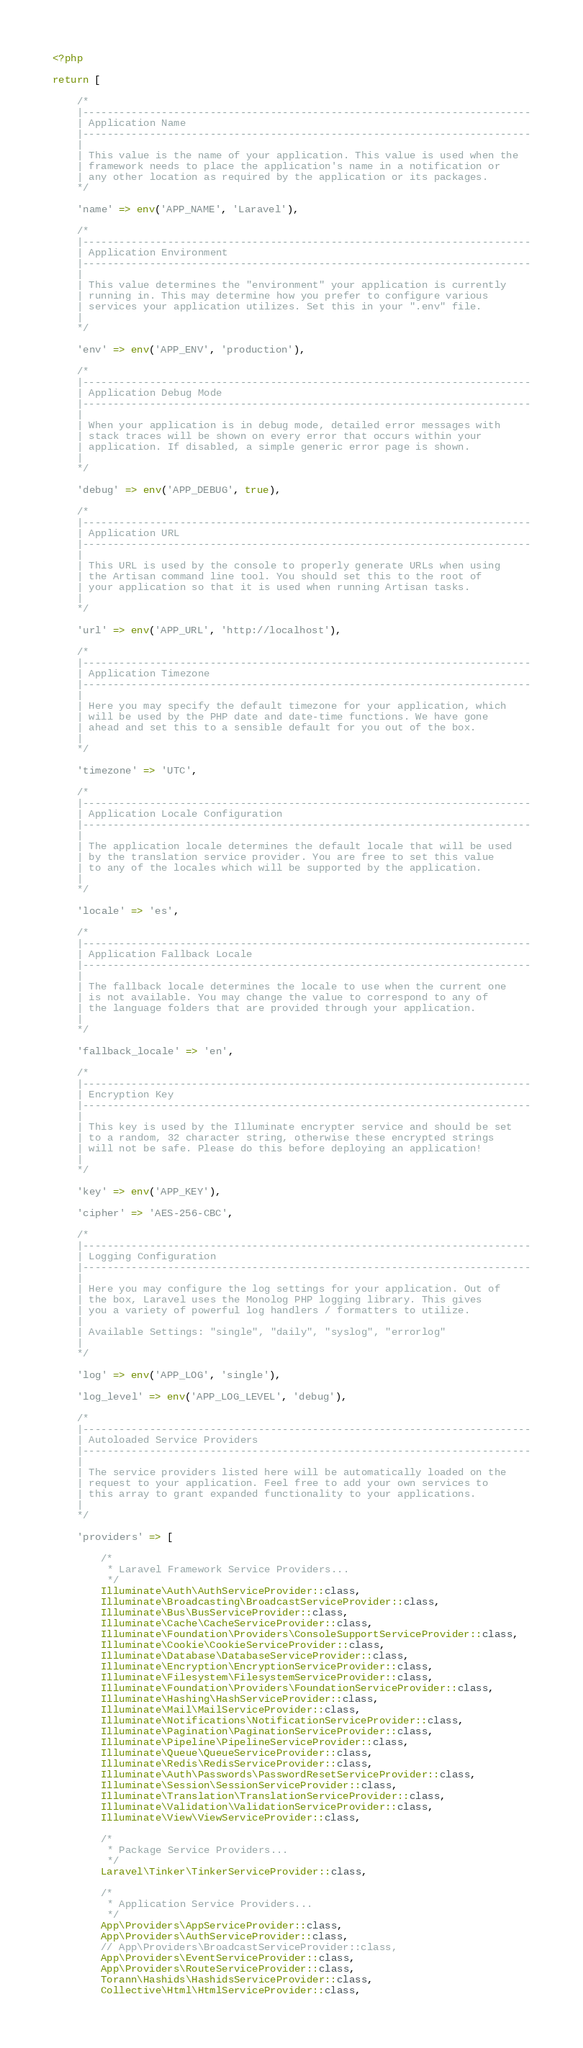Convert code to text. <code><loc_0><loc_0><loc_500><loc_500><_PHP_><?php

return [

    /*
    |--------------------------------------------------------------------------
    | Application Name
    |--------------------------------------------------------------------------
    |
    | This value is the name of your application. This value is used when the
    | framework needs to place the application's name in a notification or
    | any other location as required by the application or its packages.
    */

    'name' => env('APP_NAME', 'Laravel'),

    /*
    |--------------------------------------------------------------------------
    | Application Environment
    |--------------------------------------------------------------------------
    |
    | This value determines the "environment" your application is currently
    | running in. This may determine how you prefer to configure various
    | services your application utilizes. Set this in your ".env" file.
    |
    */

    'env' => env('APP_ENV', 'production'),

    /*
    |--------------------------------------------------------------------------
    | Application Debug Mode
    |--------------------------------------------------------------------------
    |
    | When your application is in debug mode, detailed error messages with
    | stack traces will be shown on every error that occurs within your
    | application. If disabled, a simple generic error page is shown.
    |
    */

    'debug' => env('APP_DEBUG', true),

    /*
    |--------------------------------------------------------------------------
    | Application URL
    |--------------------------------------------------------------------------
    |
    | This URL is used by the console to properly generate URLs when using
    | the Artisan command line tool. You should set this to the root of
    | your application so that it is used when running Artisan tasks.
    |
    */

    'url' => env('APP_URL', 'http://localhost'),

    /*
    |--------------------------------------------------------------------------
    | Application Timezone
    |--------------------------------------------------------------------------
    |
    | Here you may specify the default timezone for your application, which
    | will be used by the PHP date and date-time functions. We have gone
    | ahead and set this to a sensible default for you out of the box.
    |
    */

    'timezone' => 'UTC',

    /*
    |--------------------------------------------------------------------------
    | Application Locale Configuration
    |--------------------------------------------------------------------------
    |
    | The application locale determines the default locale that will be used
    | by the translation service provider. You are free to set this value
    | to any of the locales which will be supported by the application.
    |
    */

    'locale' => 'es',

    /*
    |--------------------------------------------------------------------------
    | Application Fallback Locale
    |--------------------------------------------------------------------------
    |
    | The fallback locale determines the locale to use when the current one
    | is not available. You may change the value to correspond to any of
    | the language folders that are provided through your application.
    |
    */

    'fallback_locale' => 'en',

    /*
    |--------------------------------------------------------------------------
    | Encryption Key
    |--------------------------------------------------------------------------
    |
    | This key is used by the Illuminate encrypter service and should be set
    | to a random, 32 character string, otherwise these encrypted strings
    | will not be safe. Please do this before deploying an application!
    |
    */

    'key' => env('APP_KEY'),

    'cipher' => 'AES-256-CBC',

    /*
    |--------------------------------------------------------------------------
    | Logging Configuration
    |--------------------------------------------------------------------------
    |
    | Here you may configure the log settings for your application. Out of
    | the box, Laravel uses the Monolog PHP logging library. This gives
    | you a variety of powerful log handlers / formatters to utilize.
    |
    | Available Settings: "single", "daily", "syslog", "errorlog"
    |
    */

    'log' => env('APP_LOG', 'single'),

    'log_level' => env('APP_LOG_LEVEL', 'debug'),

    /*
    |--------------------------------------------------------------------------
    | Autoloaded Service Providers
    |--------------------------------------------------------------------------
    |
    | The service providers listed here will be automatically loaded on the
    | request to your application. Feel free to add your own services to
    | this array to grant expanded functionality to your applications.
    |
    */

    'providers' => [

        /*
         * Laravel Framework Service Providers...
         */
        Illuminate\Auth\AuthServiceProvider::class,
        Illuminate\Broadcasting\BroadcastServiceProvider::class,
        Illuminate\Bus\BusServiceProvider::class,
        Illuminate\Cache\CacheServiceProvider::class,
        Illuminate\Foundation\Providers\ConsoleSupportServiceProvider::class,
        Illuminate\Cookie\CookieServiceProvider::class,
        Illuminate\Database\DatabaseServiceProvider::class,
        Illuminate\Encryption\EncryptionServiceProvider::class,
        Illuminate\Filesystem\FilesystemServiceProvider::class,
        Illuminate\Foundation\Providers\FoundationServiceProvider::class,
        Illuminate\Hashing\HashServiceProvider::class,
        Illuminate\Mail\MailServiceProvider::class,
        Illuminate\Notifications\NotificationServiceProvider::class,
        Illuminate\Pagination\PaginationServiceProvider::class,
        Illuminate\Pipeline\PipelineServiceProvider::class,
        Illuminate\Queue\QueueServiceProvider::class,
        Illuminate\Redis\RedisServiceProvider::class,
        Illuminate\Auth\Passwords\PasswordResetServiceProvider::class,
        Illuminate\Session\SessionServiceProvider::class,
        Illuminate\Translation\TranslationServiceProvider::class,
        Illuminate\Validation\ValidationServiceProvider::class,
        Illuminate\View\ViewServiceProvider::class,

        /*
         * Package Service Providers...
         */
        Laravel\Tinker\TinkerServiceProvider::class,

        /*
         * Application Service Providers...
         */
        App\Providers\AppServiceProvider::class,
        App\Providers\AuthServiceProvider::class,
        // App\Providers\BroadcastServiceProvider::class,
        App\Providers\EventServiceProvider::class,
        App\Providers\RouteServiceProvider::class,
        Torann\Hashids\HashidsServiceProvider::class,
        Collective\Html\HtmlServiceProvider::class,</code> 